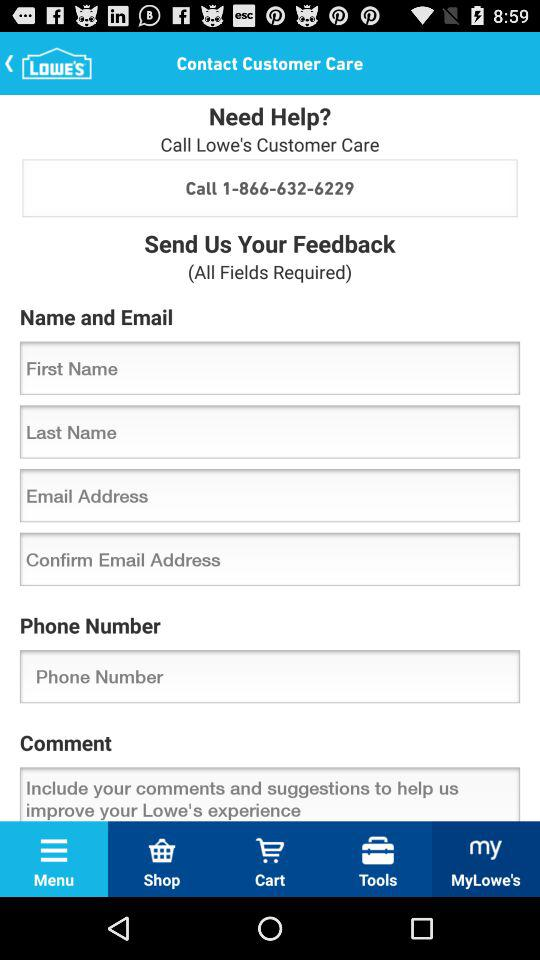How many text inputs are there that are required?
Answer the question using a single word or phrase. 6 